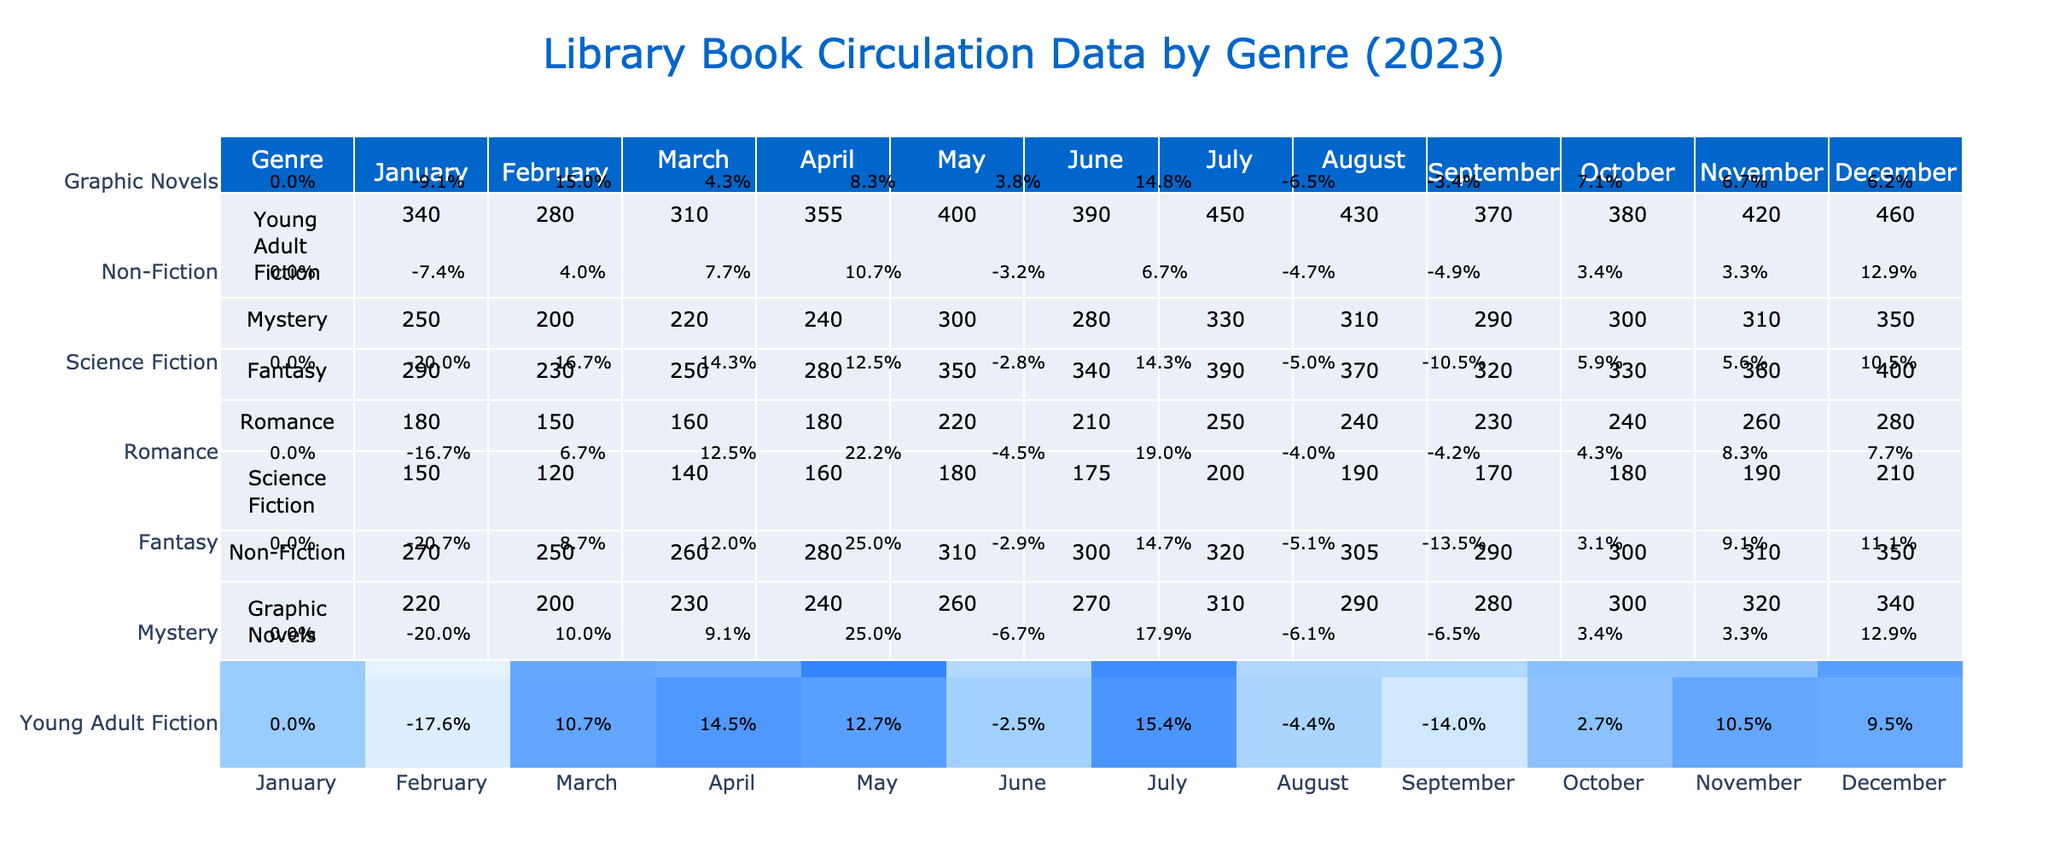What was the total circulation for Young Adult Fiction in July? The circulation for Young Adult Fiction in July is listed as 450. There is no need for further calculations, as the answer is directly available in the table.
Answer: 450 Which genre had the highest circulation in December? In December, the Highest circulation values are compared among the genres. Young Adult Fiction (460) has the highest value, while the rest are lower. Therefore, the answer is Young Adult Fiction.
Answer: Young Adult Fiction What is the average circulation of Graphic Novels over the year? The sum of Graphic Novels circulation is (220 + 200 + 230 + 240 + 260 + 270 + 310 + 290 + 280 + 300 + 320 + 340) = 3,090. The average is calculated by dividing the total by the number of months (12), giving an average of 3,090 / 12 = 257.5.
Answer: 257.5 Did Non-Fiction have a higher average circulation than Romance? First, calculate the average for Non-Fiction: (270 + 250 + 260 + 280 + 310 + 300 + 320 + 305 + 290 + 300 + 310 + 350) = 3,365 / 12 = 280.42. Next, calculate the average for Romance: (180 + 150 + 160 + 180 + 220 + 210 + 250 + 240 + 230 + 240 + 260 + 280) = 2,880 / 12 = 240. Since 280.42 is greater than 240, the statement is true.
Answer: Yes Which genre experienced the greatest percentage increase in June compared to May? We compare the percentage changes for each genre between May and June. For Young Adult Fiction, the increase is (390 - 400) / 400 = -0.025 (or -2.5%). For Mystery, the increase is (280 - 300) / 300 = -0.0667 (or -6.67%). Continuing this for all genres, we find that the Fantasy genre had the highest increase of (340 - 350) / 350 = -0.02857 (approximately -2.86%). However, for a proper answer, we would not choose the negative values; instead, we focus on the actual increases, and in this case, no genres increased from May to June. This complexity leads to the highest being -2.5%.
Answer: Young Adult Fiction (or none increased) 